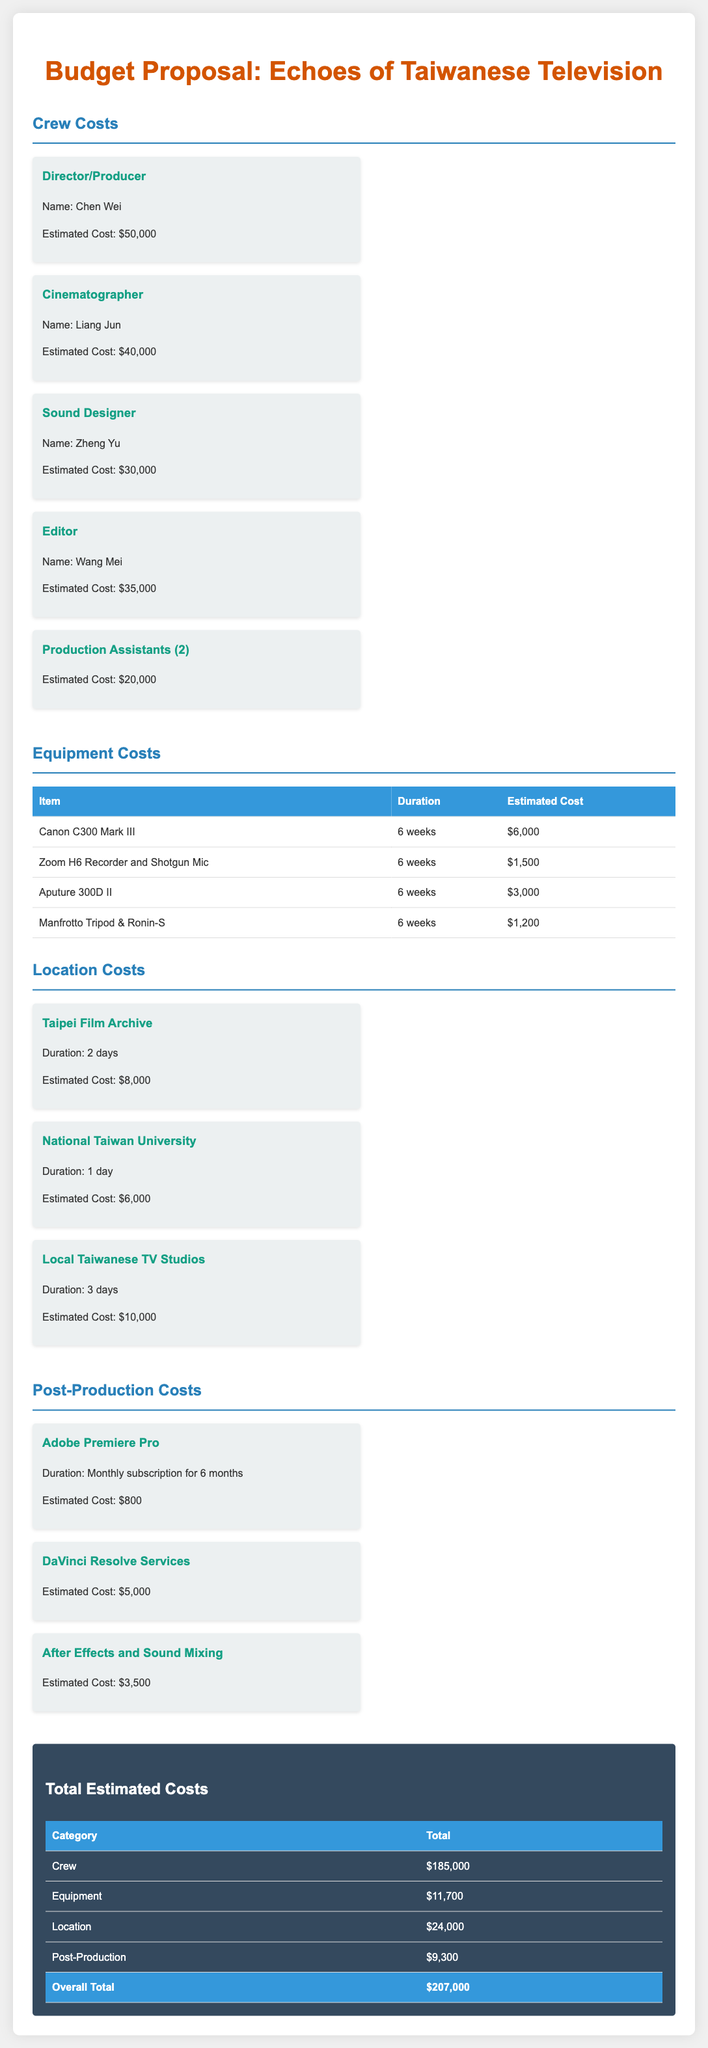What is the total estimated cost? The overall total estimated cost is provided in the document and sums up all expenses across categories.
Answer: $207,000 Who is the sound designer? The document lists the crew and identifies the individual responsible for sound design.
Answer: Zheng Yu How much does the editor cost? The document specifies the estimated cost associated with the editor’s role in the project.
Answer: $35,000 What is the estimated cost for equipment? The document contains a section that summarizes all equipment costs and gives a total for that category.
Answer: $11,700 What is the duration for using the Canon C300 Mark III? The equipment section provides durations for rental and usage of various items.
Answer: 6 weeks How many locations are listed in the budget proposal? The document mentions specific locations, which gives insight into the number of places planned for the project.
Answer: 3 What is the estimated cost for DaVinci Resolve services? The post-production costs detail the estimated expenses for various editing services, including DaVinci Resolve.
Answer: $5,000 Which city is the Taipei Film Archive located in? The location section includes the name of the primary city for each site mentioned.
Answer: Taipei What is the total cost for crew members? The document tallies all crew costs, reflecting the financial dedication to personnel in the project.
Answer: $185,000 